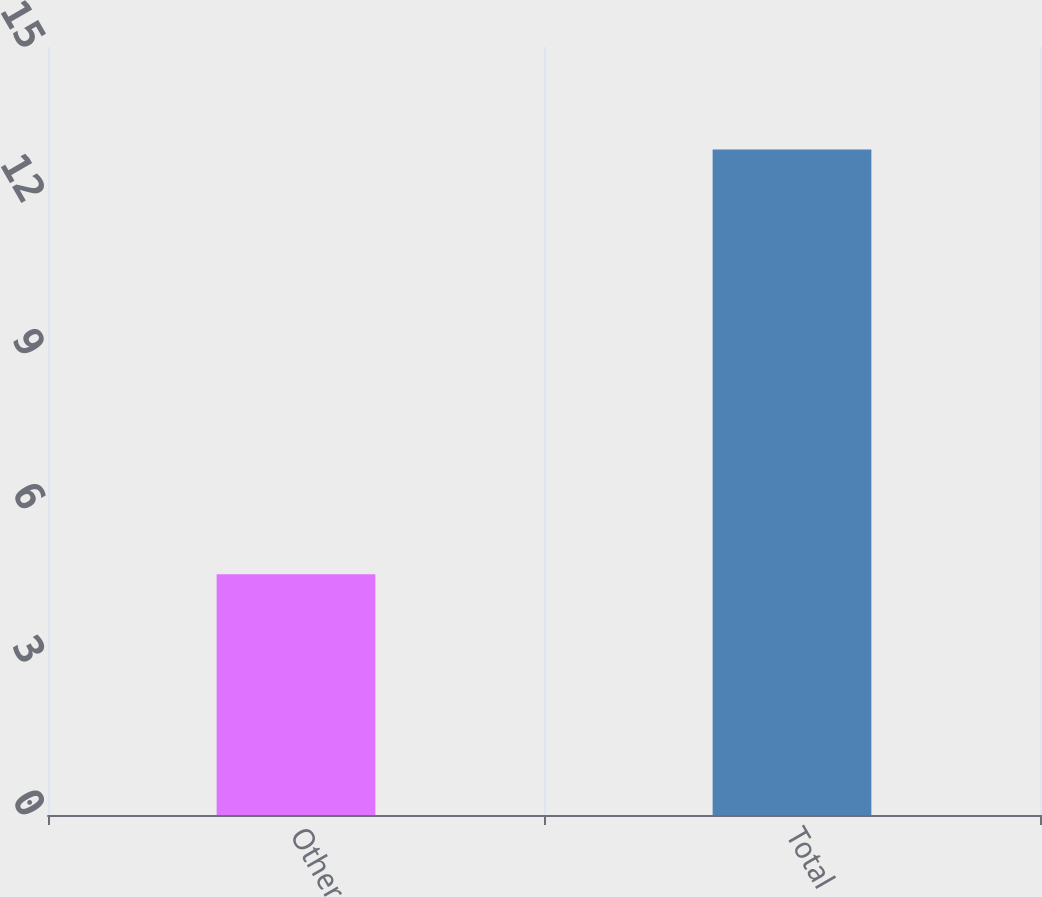Convert chart. <chart><loc_0><loc_0><loc_500><loc_500><bar_chart><fcel>Other<fcel>Total<nl><fcel>4.7<fcel>13<nl></chart> 